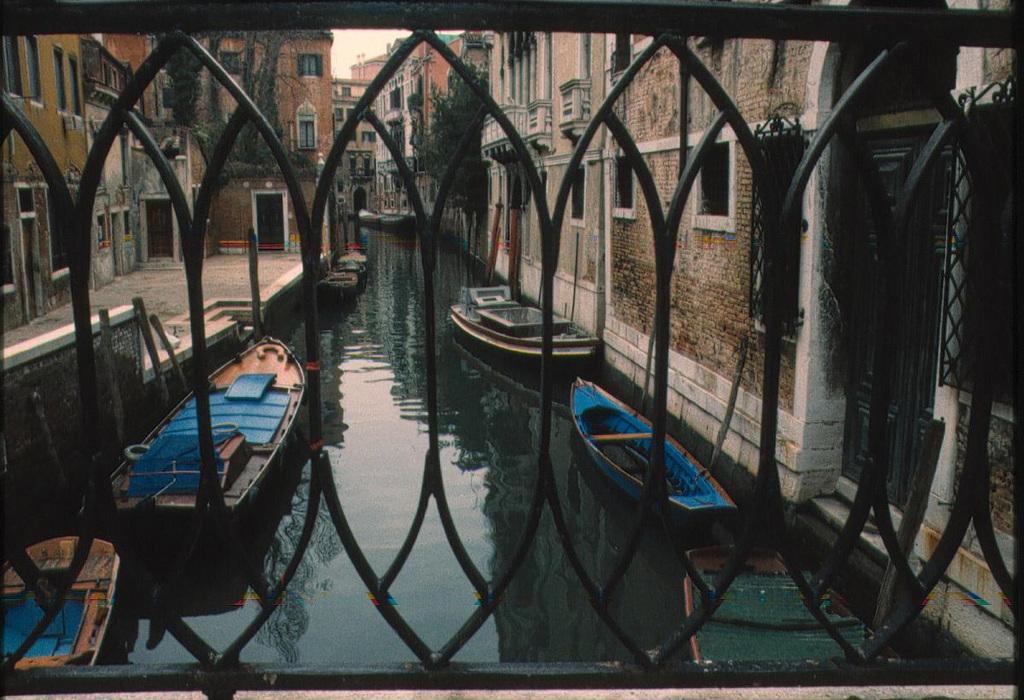Describe this image in one or two sentences. In this picture I can observe a lake. There are some boats floating on the water. I can observe black color railing. There are buildings on either sides of this lake. 